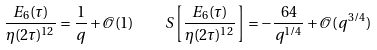<formula> <loc_0><loc_0><loc_500><loc_500>\frac { E _ { 6 } ( \tau ) } { \eta ( 2 \tau ) ^ { 1 2 } } = \frac { 1 } { q } + \mathcal { O } ( 1 ) \quad S \left [ \frac { E _ { 6 } ( \tau ) } { \eta ( 2 \tau ) ^ { 1 2 } } \right ] = - \frac { 6 4 } { q ^ { 1 / 4 } } + \mathcal { O } ( q ^ { 3 / 4 } )</formula> 